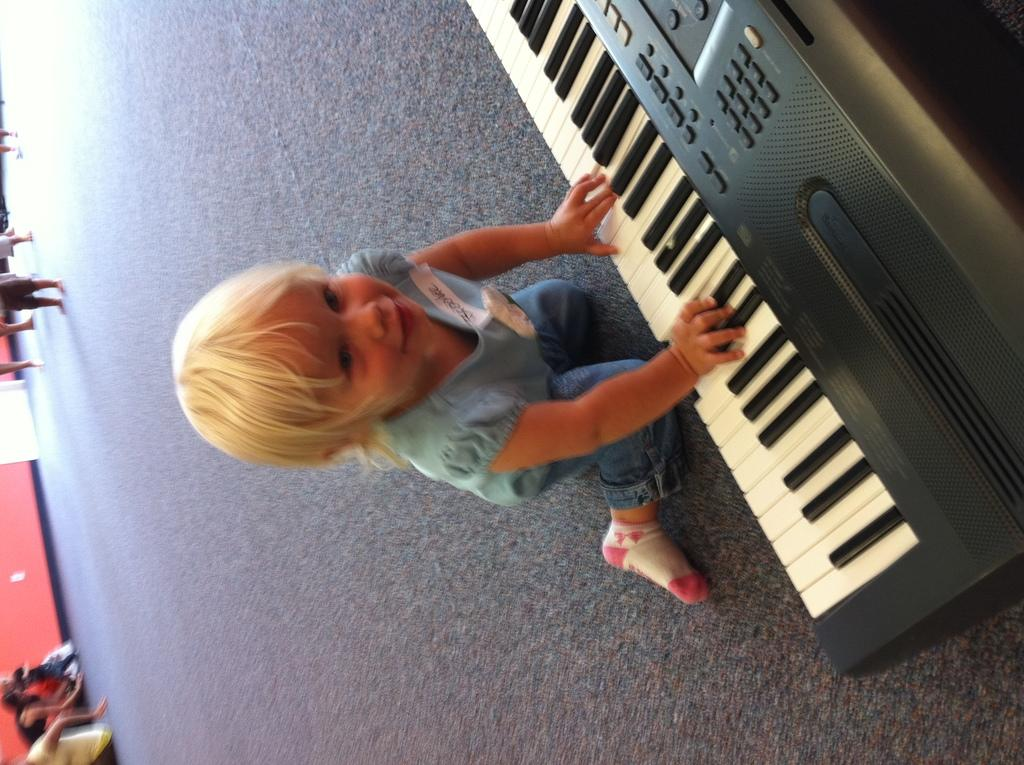What is the main subject of the image? The main subject of the image is a child. Where is the child located in the image? The child is sitting on the floor in the image. What is the child doing in the image? The child is playing a piano in the image. Can you describe the background of the image? There are people visible in the background of the image. What type of error can be seen in the image? There is no error present in the image. What kind of bells are visible in the image? There are no bells present in the image. 